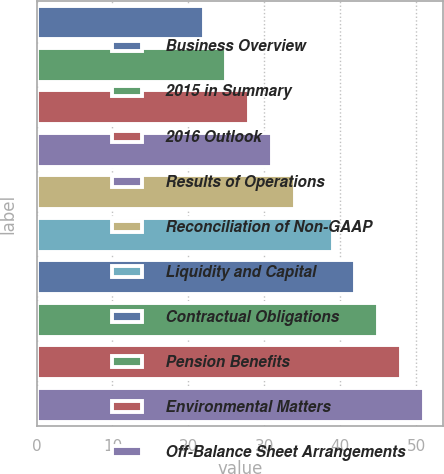Convert chart. <chart><loc_0><loc_0><loc_500><loc_500><bar_chart><fcel>Business Overview<fcel>2015 in Summary<fcel>2016 Outlook<fcel>Results of Operations<fcel>Reconciliation of Non-GAAP<fcel>Liquidity and Capital<fcel>Contractual Obligations<fcel>Pension Benefits<fcel>Environmental Matters<fcel>Off-Balance Sheet Arrangements<nl><fcel>22<fcel>25<fcel>28<fcel>31<fcel>34<fcel>39<fcel>42<fcel>45<fcel>48<fcel>51<nl></chart> 